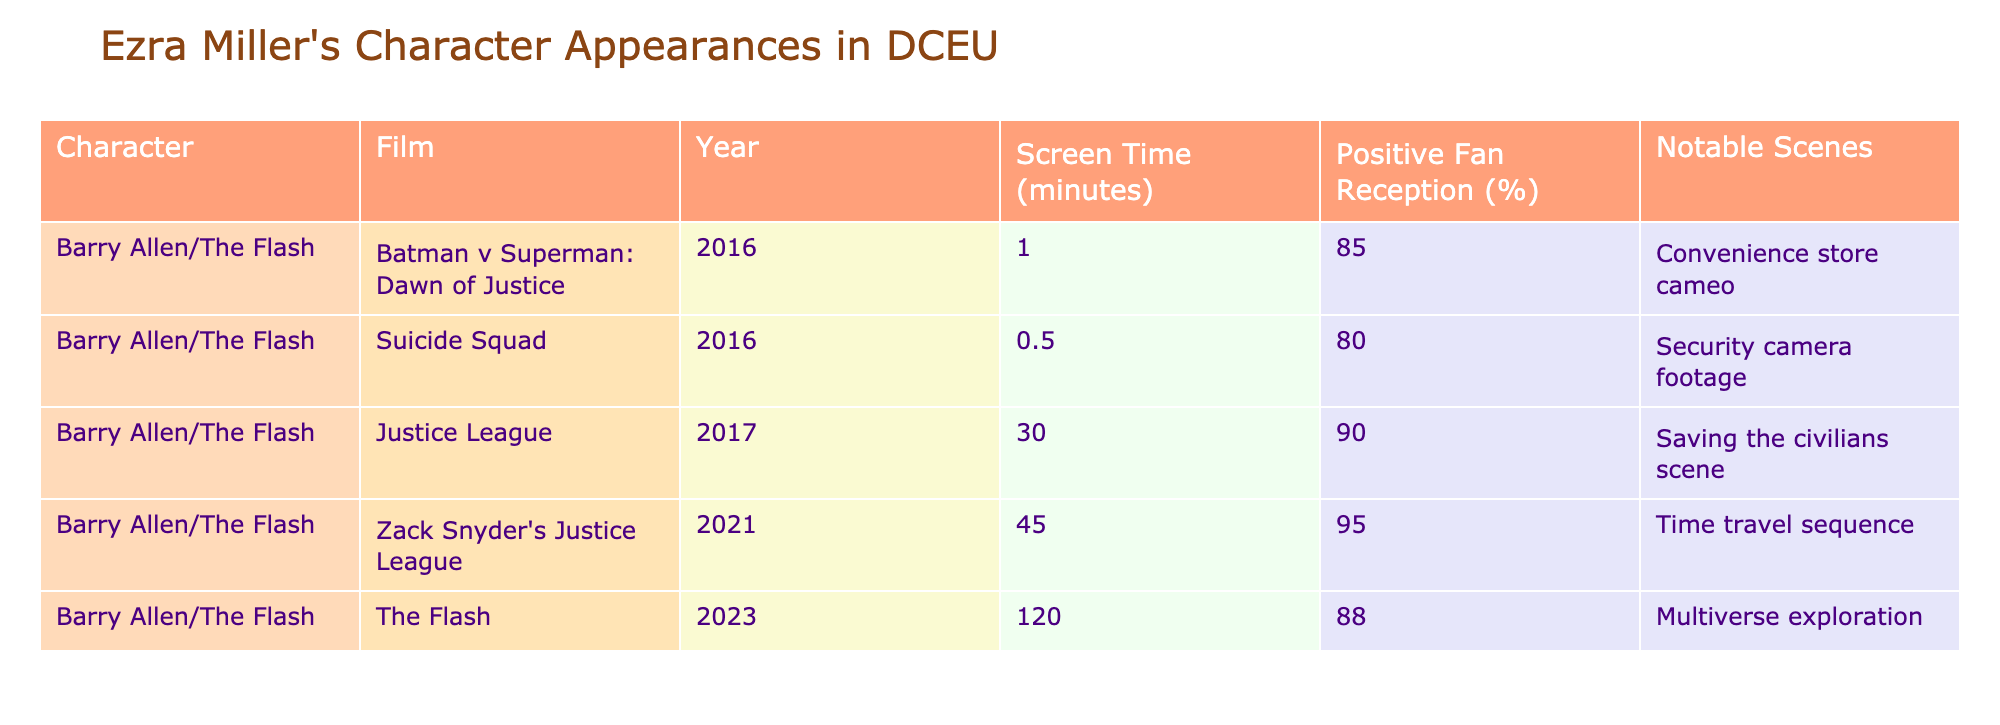What is the screen time of the character Barry Allen in "The Flash"? The table shows that the screen time for Barry Allen in "The Flash" is 120 minutes.
Answer: 120 minutes Which film has the highest positive fan reception for Barry Allen? According to the table, "Zack Snyder's Justice League" has the highest positive fan reception at 95%.
Answer: Zack Snyder's Justice League What is the average screen time of Barry Allen across all films listed? To find the average screen time, we sum all the screen times: 1 + 0.5 + 30 + 45 + 120 = 196 minutes. There are 5 films, so the average is 196/5 = 39.2 minutes.
Answer: 39.2 minutes Did Barry Allen appear in "Suicide Squad"? Yes, the table confirms that Barry Allen is listed as appearing in "Suicide Squad" with a screen time of 0.5 minutes.
Answer: Yes In which film did Barry Allen have notable scenes involving time travel? The table indicates that the notable scene involving time travel occurs in "Zack Snyder's Justice League."
Answer: Zack Snyder's Justice League What is the difference in screen time between Barry Allen in "Justice League" and "The Flash"? Barry Allen has 30 minutes of screen time in "Justice League" and 120 minutes in "The Flash." The difference is 120 - 30 = 90 minutes.
Answer: 90 minutes Which film features Barry Allen's character with the least amount of screen time? The table shows that the film with the least screen time for Barry Allen is "Batman v Superman: Dawn of Justice" with just 1 minute.
Answer: Batman v Superman: Dawn of Justice How many films feature Barry Allen with a positive fan reception of 85% or higher? The table lists five films featuring Barry Allen, and four of them have a positive fan reception of 85% or higher: "Batman v Superman: Dawn of Justice," "Justice League," "Zack Snyder's Justice League," and "The Flash." Therefore, there are four films.
Answer: 4 films 